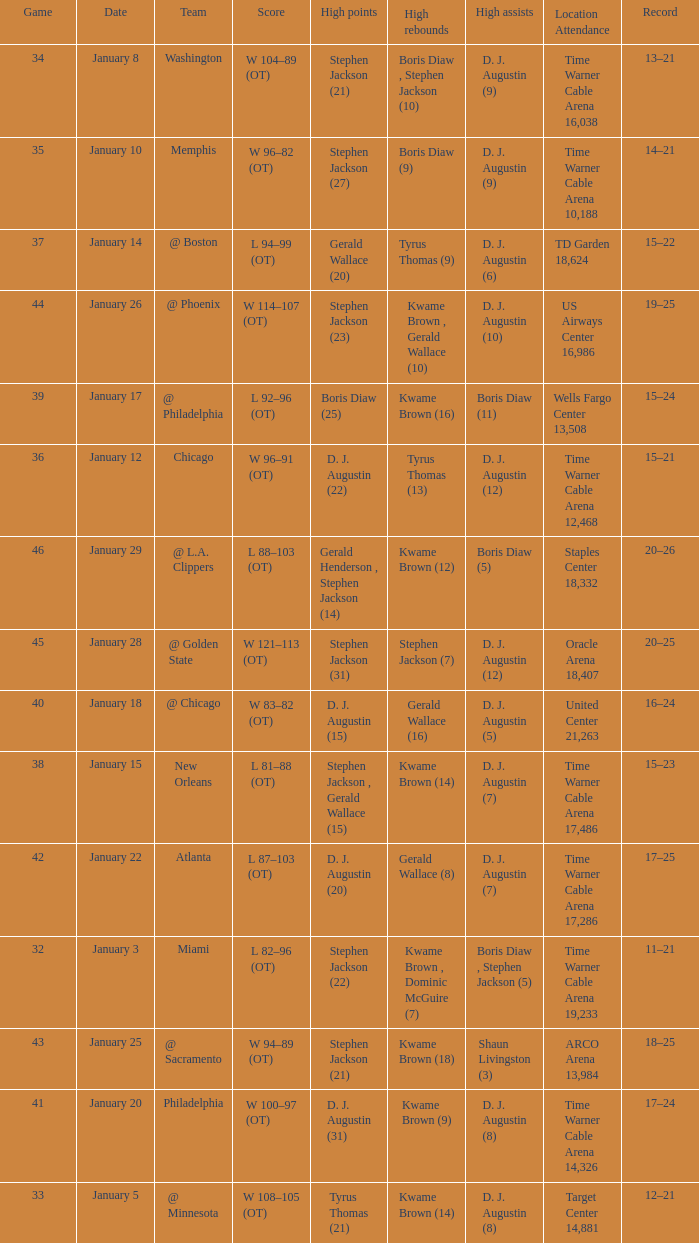How many high rebounds are listed for game 35? 1.0. 